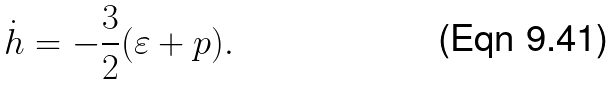Convert formula to latex. <formula><loc_0><loc_0><loc_500><loc_500>\dot { h } = - \frac { 3 } { 2 } ( \varepsilon + p ) .</formula> 